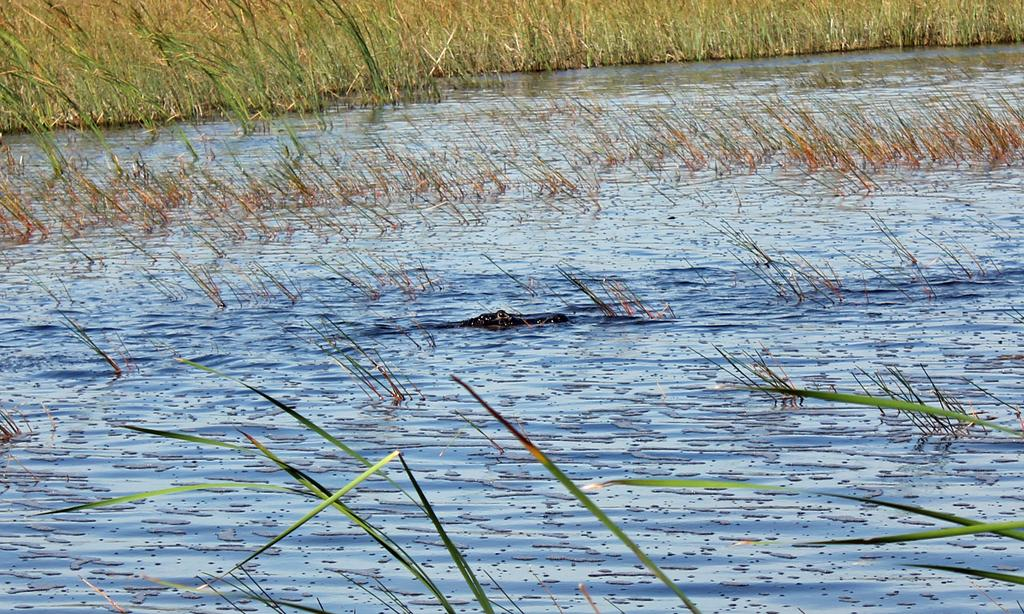What is the primary element in the image? The image consists of water. What animal can be seen in the water? There is a crocodile in the water. What type of vegetation is visible in the background of the image? There is grass in the background of the image. What type of amusement can be seen in the image? There is no amusement present in the image; it consists of water with a crocodile and grass in the background. How many houses are visible in the image? There are no houses visible in the image; it consists of water with a crocodile and grass in the background. 